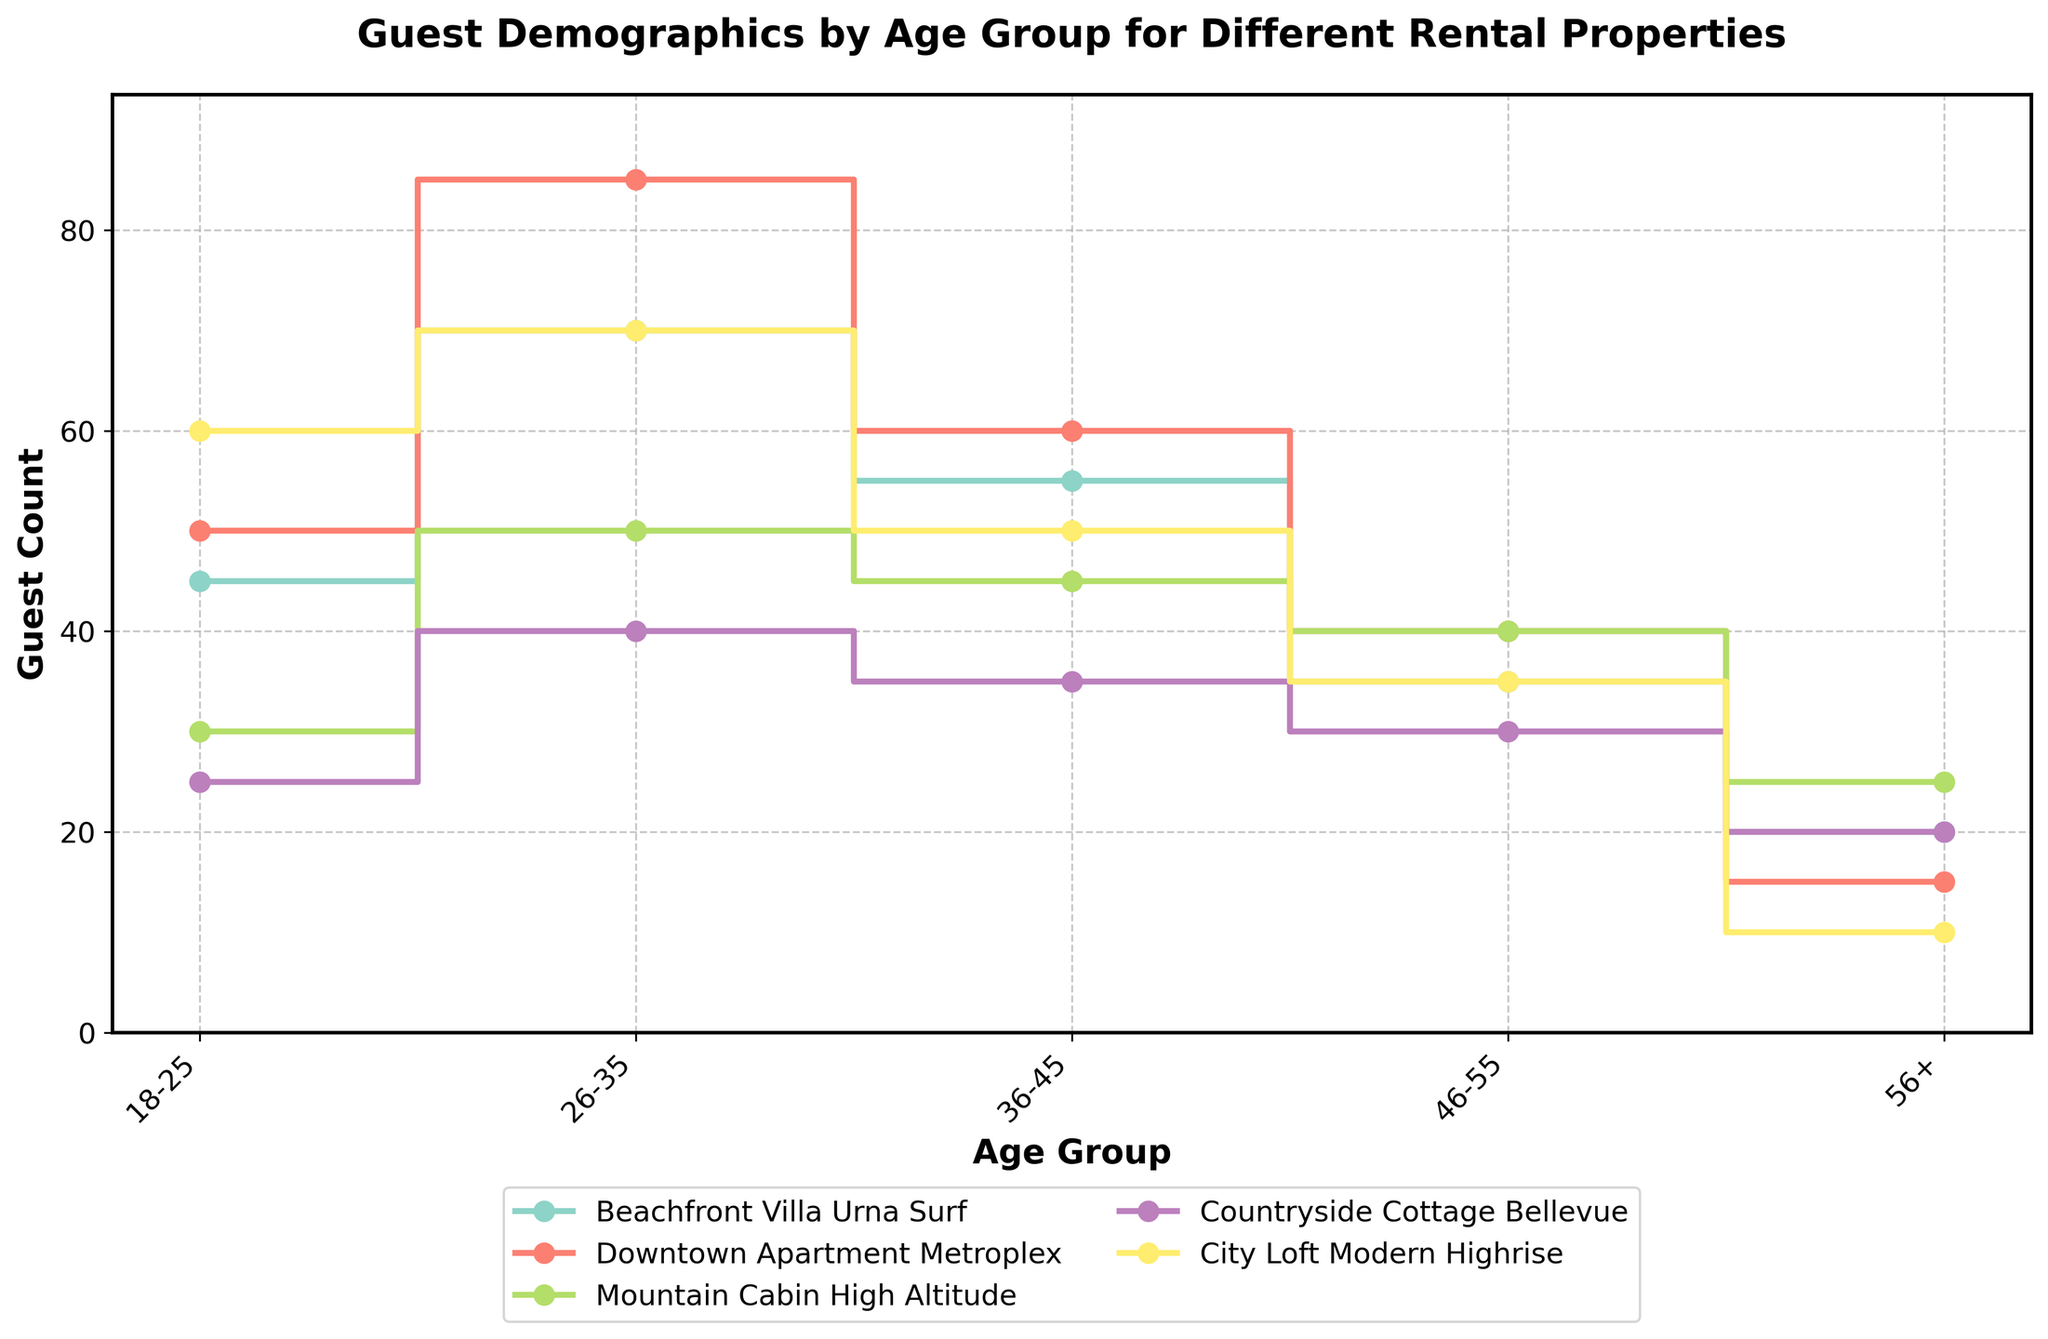What is the title of the plot? The title is displayed at the top of the plot in bold font.
Answer: Guest Demographics by Age Group for Different Rental Properties Which property has the highest guest count in the 18-25 age group? Look at the y-axis value for each property in the 18-25 category.
Answer: City Loft Modern Highrise How many properties are compared in the plot? Count the number of different lines or legends in the plot.
Answer: 5 What is the guest count for Beachfront Villa Urna Surf in the 26-35 age group? Find the line corresponding to Beachfront Villa Urna Surf and read the value for the 26-35 category on the y-axis.
Answer: 70 Which age group has the lowest guest count for Downtown Apartment Metroplex? Identify the line for Downtown Apartment Metroplex and find the lowest value on the y-axis.
Answer: 56+ Which property shows the most even distribution of guest counts across different age groups? Look for the line where the guest counts are relatively similar across age groups. This is the most even distribution.
Answer: Mountain Cabin High Altitude What is the difference in guest count between the 26-35 and 56+ age groups for City Loft Modern Highrise? Subtract the guest count in the 56+ age group from the guest count in the 26-35 age group for City Loft Modern Highrise.
Answer: 60 In which age group does Countryside Cottage Bellevue have the highest number of guests? Find the highest y-axis value for Countryside Cottage Bellevue and note the corresponding age group.
Answer: 26-35 How does the guest count for the 36-45 age group in Downtown Apartment Metroplex compare with Beachfront Villa Urna Surf? Find the guest counts for both properties in the 36-45 age group and compare them.
Answer: Downtown Apartment Metroplex has more guests Which property has the largest decrease in guest count between the 36-45 and 46-55 age groups? Look at all properties and find the one with the largest drop in guest count when moving from the 36-45 to the 46-55 age group.
Answer: Beachfront Villa Urna Surf 